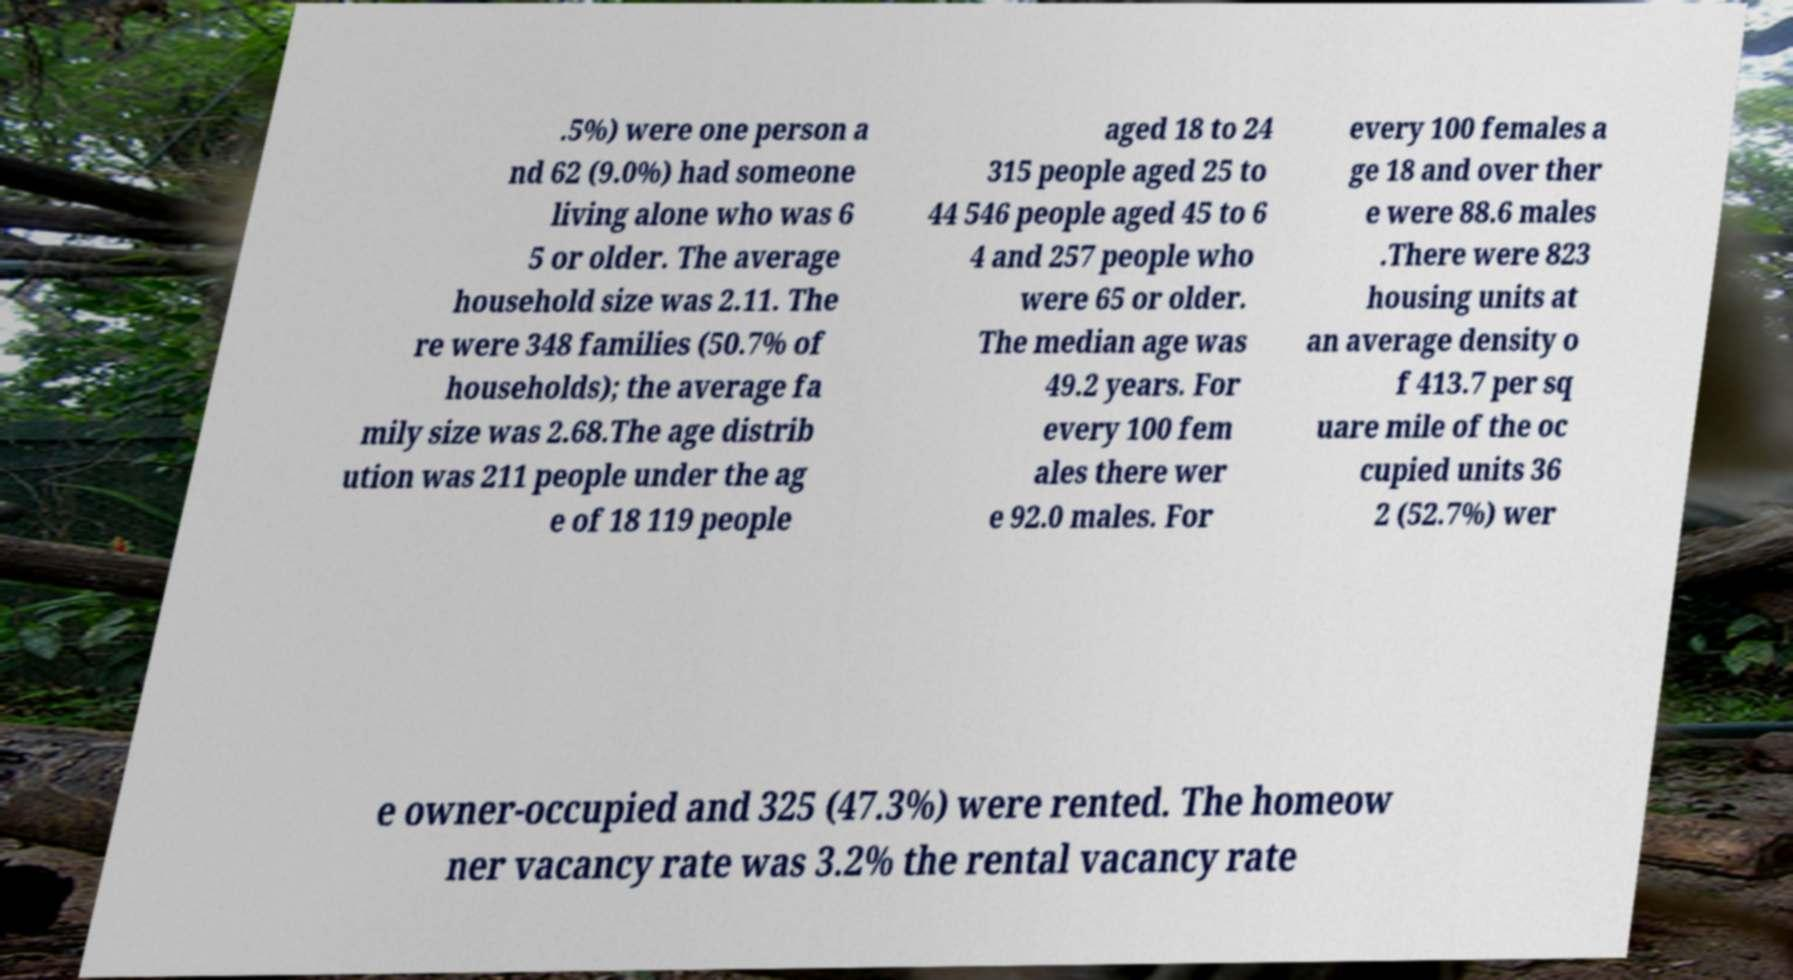There's text embedded in this image that I need extracted. Can you transcribe it verbatim? .5%) were one person a nd 62 (9.0%) had someone living alone who was 6 5 or older. The average household size was 2.11. The re were 348 families (50.7% of households); the average fa mily size was 2.68.The age distrib ution was 211 people under the ag e of 18 119 people aged 18 to 24 315 people aged 25 to 44 546 people aged 45 to 6 4 and 257 people who were 65 or older. The median age was 49.2 years. For every 100 fem ales there wer e 92.0 males. For every 100 females a ge 18 and over ther e were 88.6 males .There were 823 housing units at an average density o f 413.7 per sq uare mile of the oc cupied units 36 2 (52.7%) wer e owner-occupied and 325 (47.3%) were rented. The homeow ner vacancy rate was 3.2% the rental vacancy rate 